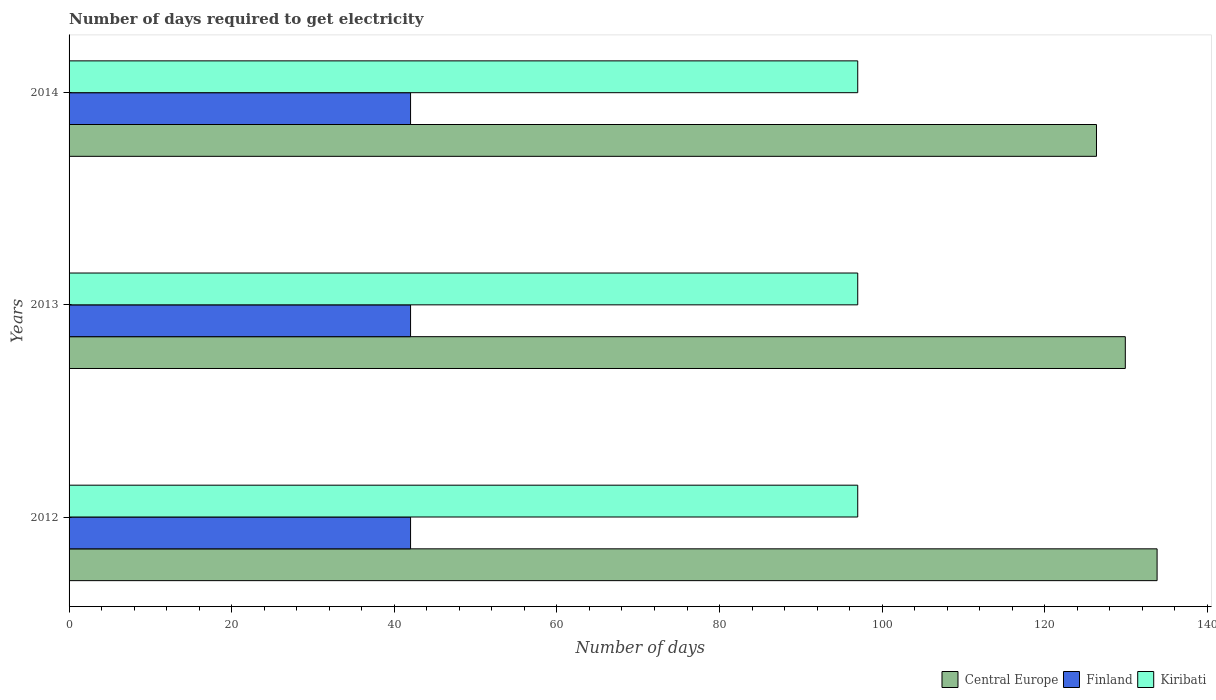How many groups of bars are there?
Ensure brevity in your answer.  3. Are the number of bars per tick equal to the number of legend labels?
Keep it short and to the point. Yes. Are the number of bars on each tick of the Y-axis equal?
Your response must be concise. Yes. How many bars are there on the 1st tick from the top?
Offer a terse response. 3. What is the label of the 2nd group of bars from the top?
Keep it short and to the point. 2013. What is the number of days required to get electricity in in Central Europe in 2014?
Ensure brevity in your answer.  126.36. Across all years, what is the maximum number of days required to get electricity in in Kiribati?
Your answer should be very brief. 97. Across all years, what is the minimum number of days required to get electricity in in Central Europe?
Offer a very short reply. 126.36. In which year was the number of days required to get electricity in in Central Europe maximum?
Make the answer very short. 2012. What is the total number of days required to get electricity in in Central Europe in the graph?
Keep it short and to the point. 390.09. What is the difference between the number of days required to get electricity in in Kiribati in 2012 and that in 2014?
Make the answer very short. 0. What is the difference between the number of days required to get electricity in in Central Europe in 2014 and the number of days required to get electricity in in Finland in 2012?
Provide a succinct answer. 84.36. What is the average number of days required to get electricity in in Central Europe per year?
Offer a terse response. 130.03. In the year 2012, what is the difference between the number of days required to get electricity in in Finland and number of days required to get electricity in in Central Europe?
Your answer should be compact. -91.82. In how many years, is the number of days required to get electricity in in Finland greater than 108 days?
Provide a succinct answer. 0. What is the ratio of the number of days required to get electricity in in Finland in 2013 to that in 2014?
Give a very brief answer. 1. Is the number of days required to get electricity in in Finland in 2013 less than that in 2014?
Provide a short and direct response. No. Is the sum of the number of days required to get electricity in in Central Europe in 2012 and 2013 greater than the maximum number of days required to get electricity in in Finland across all years?
Offer a very short reply. Yes. What does the 3rd bar from the top in 2012 represents?
Offer a very short reply. Central Europe. What does the 3rd bar from the bottom in 2012 represents?
Offer a terse response. Kiribati. Is it the case that in every year, the sum of the number of days required to get electricity in in Central Europe and number of days required to get electricity in in Finland is greater than the number of days required to get electricity in in Kiribati?
Provide a succinct answer. Yes. Does the graph contain grids?
Keep it short and to the point. No. Where does the legend appear in the graph?
Keep it short and to the point. Bottom right. How are the legend labels stacked?
Ensure brevity in your answer.  Horizontal. What is the title of the graph?
Ensure brevity in your answer.  Number of days required to get electricity. What is the label or title of the X-axis?
Offer a very short reply. Number of days. What is the label or title of the Y-axis?
Make the answer very short. Years. What is the Number of days of Central Europe in 2012?
Provide a short and direct response. 133.82. What is the Number of days of Finland in 2012?
Ensure brevity in your answer.  42. What is the Number of days of Kiribati in 2012?
Make the answer very short. 97. What is the Number of days of Central Europe in 2013?
Your response must be concise. 129.91. What is the Number of days in Finland in 2013?
Offer a terse response. 42. What is the Number of days of Kiribati in 2013?
Ensure brevity in your answer.  97. What is the Number of days in Central Europe in 2014?
Give a very brief answer. 126.36. What is the Number of days in Finland in 2014?
Ensure brevity in your answer.  42. What is the Number of days of Kiribati in 2014?
Offer a very short reply. 97. Across all years, what is the maximum Number of days in Central Europe?
Provide a short and direct response. 133.82. Across all years, what is the maximum Number of days in Finland?
Your answer should be compact. 42. Across all years, what is the maximum Number of days of Kiribati?
Offer a very short reply. 97. Across all years, what is the minimum Number of days in Central Europe?
Provide a short and direct response. 126.36. Across all years, what is the minimum Number of days of Finland?
Your answer should be very brief. 42. Across all years, what is the minimum Number of days of Kiribati?
Provide a succinct answer. 97. What is the total Number of days of Central Europe in the graph?
Your response must be concise. 390.09. What is the total Number of days in Finland in the graph?
Keep it short and to the point. 126. What is the total Number of days of Kiribati in the graph?
Provide a succinct answer. 291. What is the difference between the Number of days in Central Europe in 2012 and that in 2013?
Your answer should be compact. 3.91. What is the difference between the Number of days in Central Europe in 2012 and that in 2014?
Provide a succinct answer. 7.45. What is the difference between the Number of days of Finland in 2012 and that in 2014?
Give a very brief answer. 0. What is the difference between the Number of days of Central Europe in 2013 and that in 2014?
Keep it short and to the point. 3.55. What is the difference between the Number of days in Finland in 2013 and that in 2014?
Keep it short and to the point. 0. What is the difference between the Number of days of Kiribati in 2013 and that in 2014?
Provide a succinct answer. 0. What is the difference between the Number of days in Central Europe in 2012 and the Number of days in Finland in 2013?
Your answer should be compact. 91.82. What is the difference between the Number of days in Central Europe in 2012 and the Number of days in Kiribati in 2013?
Provide a succinct answer. 36.82. What is the difference between the Number of days in Finland in 2012 and the Number of days in Kiribati in 2013?
Give a very brief answer. -55. What is the difference between the Number of days of Central Europe in 2012 and the Number of days of Finland in 2014?
Keep it short and to the point. 91.82. What is the difference between the Number of days of Central Europe in 2012 and the Number of days of Kiribati in 2014?
Your answer should be very brief. 36.82. What is the difference between the Number of days of Finland in 2012 and the Number of days of Kiribati in 2014?
Provide a succinct answer. -55. What is the difference between the Number of days in Central Europe in 2013 and the Number of days in Finland in 2014?
Your answer should be very brief. 87.91. What is the difference between the Number of days of Central Europe in 2013 and the Number of days of Kiribati in 2014?
Your answer should be compact. 32.91. What is the difference between the Number of days in Finland in 2013 and the Number of days in Kiribati in 2014?
Give a very brief answer. -55. What is the average Number of days in Central Europe per year?
Keep it short and to the point. 130.03. What is the average Number of days in Finland per year?
Your answer should be very brief. 42. What is the average Number of days in Kiribati per year?
Offer a very short reply. 97. In the year 2012, what is the difference between the Number of days in Central Europe and Number of days in Finland?
Offer a very short reply. 91.82. In the year 2012, what is the difference between the Number of days in Central Europe and Number of days in Kiribati?
Keep it short and to the point. 36.82. In the year 2012, what is the difference between the Number of days in Finland and Number of days in Kiribati?
Make the answer very short. -55. In the year 2013, what is the difference between the Number of days of Central Europe and Number of days of Finland?
Offer a very short reply. 87.91. In the year 2013, what is the difference between the Number of days of Central Europe and Number of days of Kiribati?
Offer a terse response. 32.91. In the year 2013, what is the difference between the Number of days in Finland and Number of days in Kiribati?
Offer a very short reply. -55. In the year 2014, what is the difference between the Number of days in Central Europe and Number of days in Finland?
Give a very brief answer. 84.36. In the year 2014, what is the difference between the Number of days in Central Europe and Number of days in Kiribati?
Provide a short and direct response. 29.36. In the year 2014, what is the difference between the Number of days in Finland and Number of days in Kiribati?
Ensure brevity in your answer.  -55. What is the ratio of the Number of days in Central Europe in 2012 to that in 2013?
Make the answer very short. 1.03. What is the ratio of the Number of days of Kiribati in 2012 to that in 2013?
Provide a succinct answer. 1. What is the ratio of the Number of days in Central Europe in 2012 to that in 2014?
Offer a very short reply. 1.06. What is the ratio of the Number of days of Kiribati in 2012 to that in 2014?
Make the answer very short. 1. What is the ratio of the Number of days of Central Europe in 2013 to that in 2014?
Your response must be concise. 1.03. What is the difference between the highest and the second highest Number of days of Central Europe?
Give a very brief answer. 3.91. What is the difference between the highest and the second highest Number of days in Finland?
Your response must be concise. 0. What is the difference between the highest and the lowest Number of days in Central Europe?
Provide a succinct answer. 7.45. What is the difference between the highest and the lowest Number of days in Kiribati?
Provide a succinct answer. 0. 